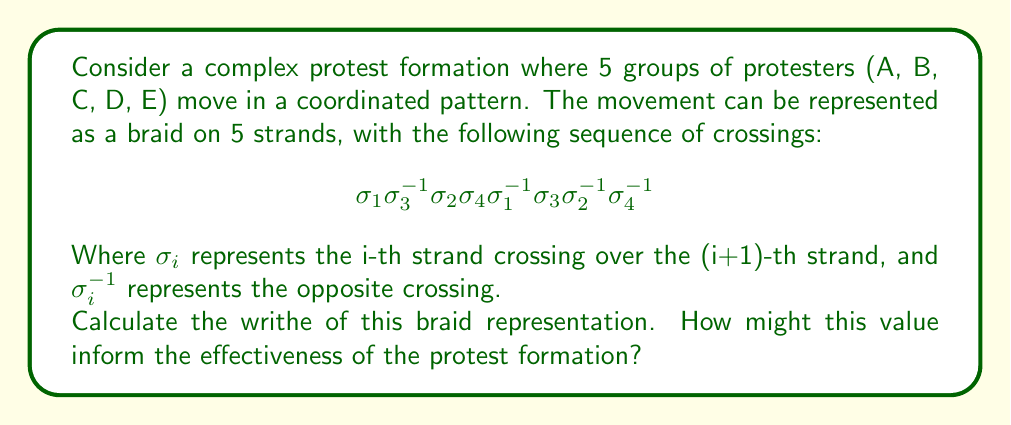Could you help me with this problem? To solve this problem, we need to follow these steps:

1) Recall that the writhe of a braid is the sum of the exponents of the $\sigma_i$ terms in the braid word.

2) In our braid word:
   $$\sigma_1 \sigma_3^{-1} \sigma_2 \sigma_4 \sigma_1^{-1} \sigma_3 \sigma_2^{-1} \sigma_4^{-1}$$

3) Let's count the contribution of each term:
   - $\sigma_1$: +1
   - $\sigma_3^{-1}$: -1
   - $\sigma_2$: +1
   - $\sigma_4$: +1
   - $\sigma_1^{-1}$: -1
   - $\sigma_3$: +1
   - $\sigma_2^{-1}$: -1
   - $\sigma_4^{-1}$: -1

4) Sum up all these values: 1 + (-1) + 1 + 1 + (-1) + 1 + (-1) + (-1) = 0

5) Therefore, the writhe of this braid is 0.

6) Interpretation for protest effectiveness:
   A writhe of 0 suggests a balanced movement pattern. In the context of a protest, this could indicate a formation that is complex enough to be visually impactful and difficult to disrupt, yet structured enough to maintain cohesion. The balanced nature (positive and negative crossings cancelling out) might symbolize a protest strategy that is neither too aggressive nor too passive, potentially striking an effective middle ground.
Answer: 0 